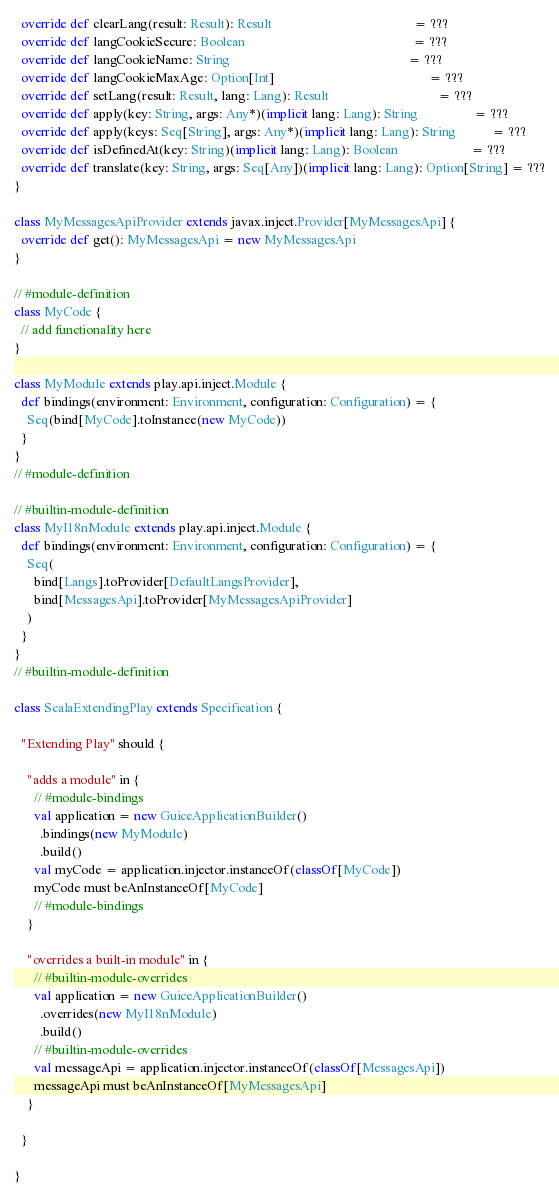Convert code to text. <code><loc_0><loc_0><loc_500><loc_500><_Scala_>  override def clearLang(result: Result): Result                                           = ???
  override def langCookieSecure: Boolean                                                   = ???
  override def langCookieName: String                                                      = ???
  override def langCookieMaxAge: Option[Int]                                               = ???
  override def setLang(result: Result, lang: Lang): Result                                 = ???
  override def apply(key: String, args: Any*)(implicit lang: Lang): String                 = ???
  override def apply(keys: Seq[String], args: Any*)(implicit lang: Lang): String           = ???
  override def isDefinedAt(key: String)(implicit lang: Lang): Boolean                      = ???
  override def translate(key: String, args: Seq[Any])(implicit lang: Lang): Option[String] = ???
}

class MyMessagesApiProvider extends javax.inject.Provider[MyMessagesApi] {
  override def get(): MyMessagesApi = new MyMessagesApi
}

// #module-definition
class MyCode {
  // add functionality here
}

class MyModule extends play.api.inject.Module {
  def bindings(environment: Environment, configuration: Configuration) = {
    Seq(bind[MyCode].toInstance(new MyCode))
  }
}
// #module-definition

// #builtin-module-definition
class MyI18nModule extends play.api.inject.Module {
  def bindings(environment: Environment, configuration: Configuration) = {
    Seq(
      bind[Langs].toProvider[DefaultLangsProvider],
      bind[MessagesApi].toProvider[MyMessagesApiProvider]
    )
  }
}
// #builtin-module-definition

class ScalaExtendingPlay extends Specification {

  "Extending Play" should {

    "adds a module" in {
      // #module-bindings
      val application = new GuiceApplicationBuilder()
        .bindings(new MyModule)
        .build()
      val myCode = application.injector.instanceOf(classOf[MyCode])
      myCode must beAnInstanceOf[MyCode]
      // #module-bindings
    }

    "overrides a built-in module" in {
      // #builtin-module-overrides
      val application = new GuiceApplicationBuilder()
        .overrides(new MyI18nModule)
        .build()
      // #builtin-module-overrides
      val messageApi = application.injector.instanceOf(classOf[MessagesApi])
      messageApi must beAnInstanceOf[MyMessagesApi]
    }

  }

}
</code> 